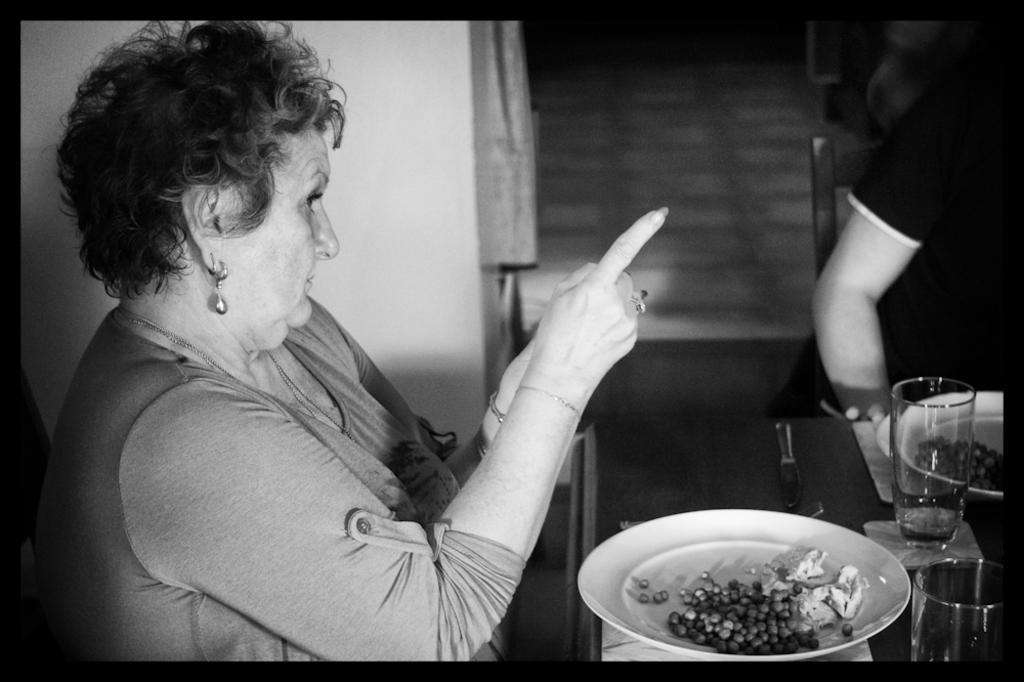Please provide a concise description of this image. This is a black and white image. In this image we can see persons sitting on the chairs and a table is placed in front of them. On the table we can see coasters, glass tumblers, cutlery and serving plates with food on them. 